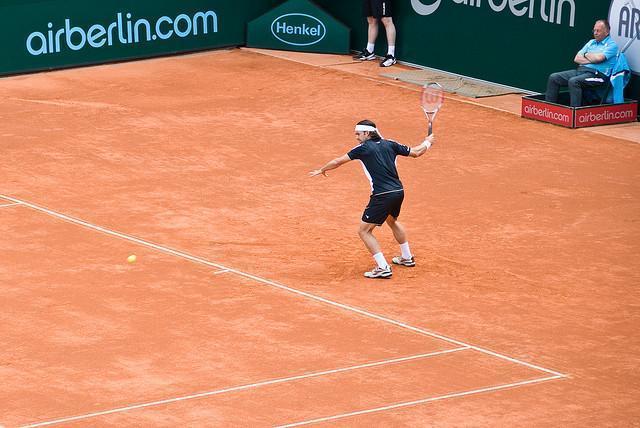How many people are there?
Give a very brief answer. 2. 